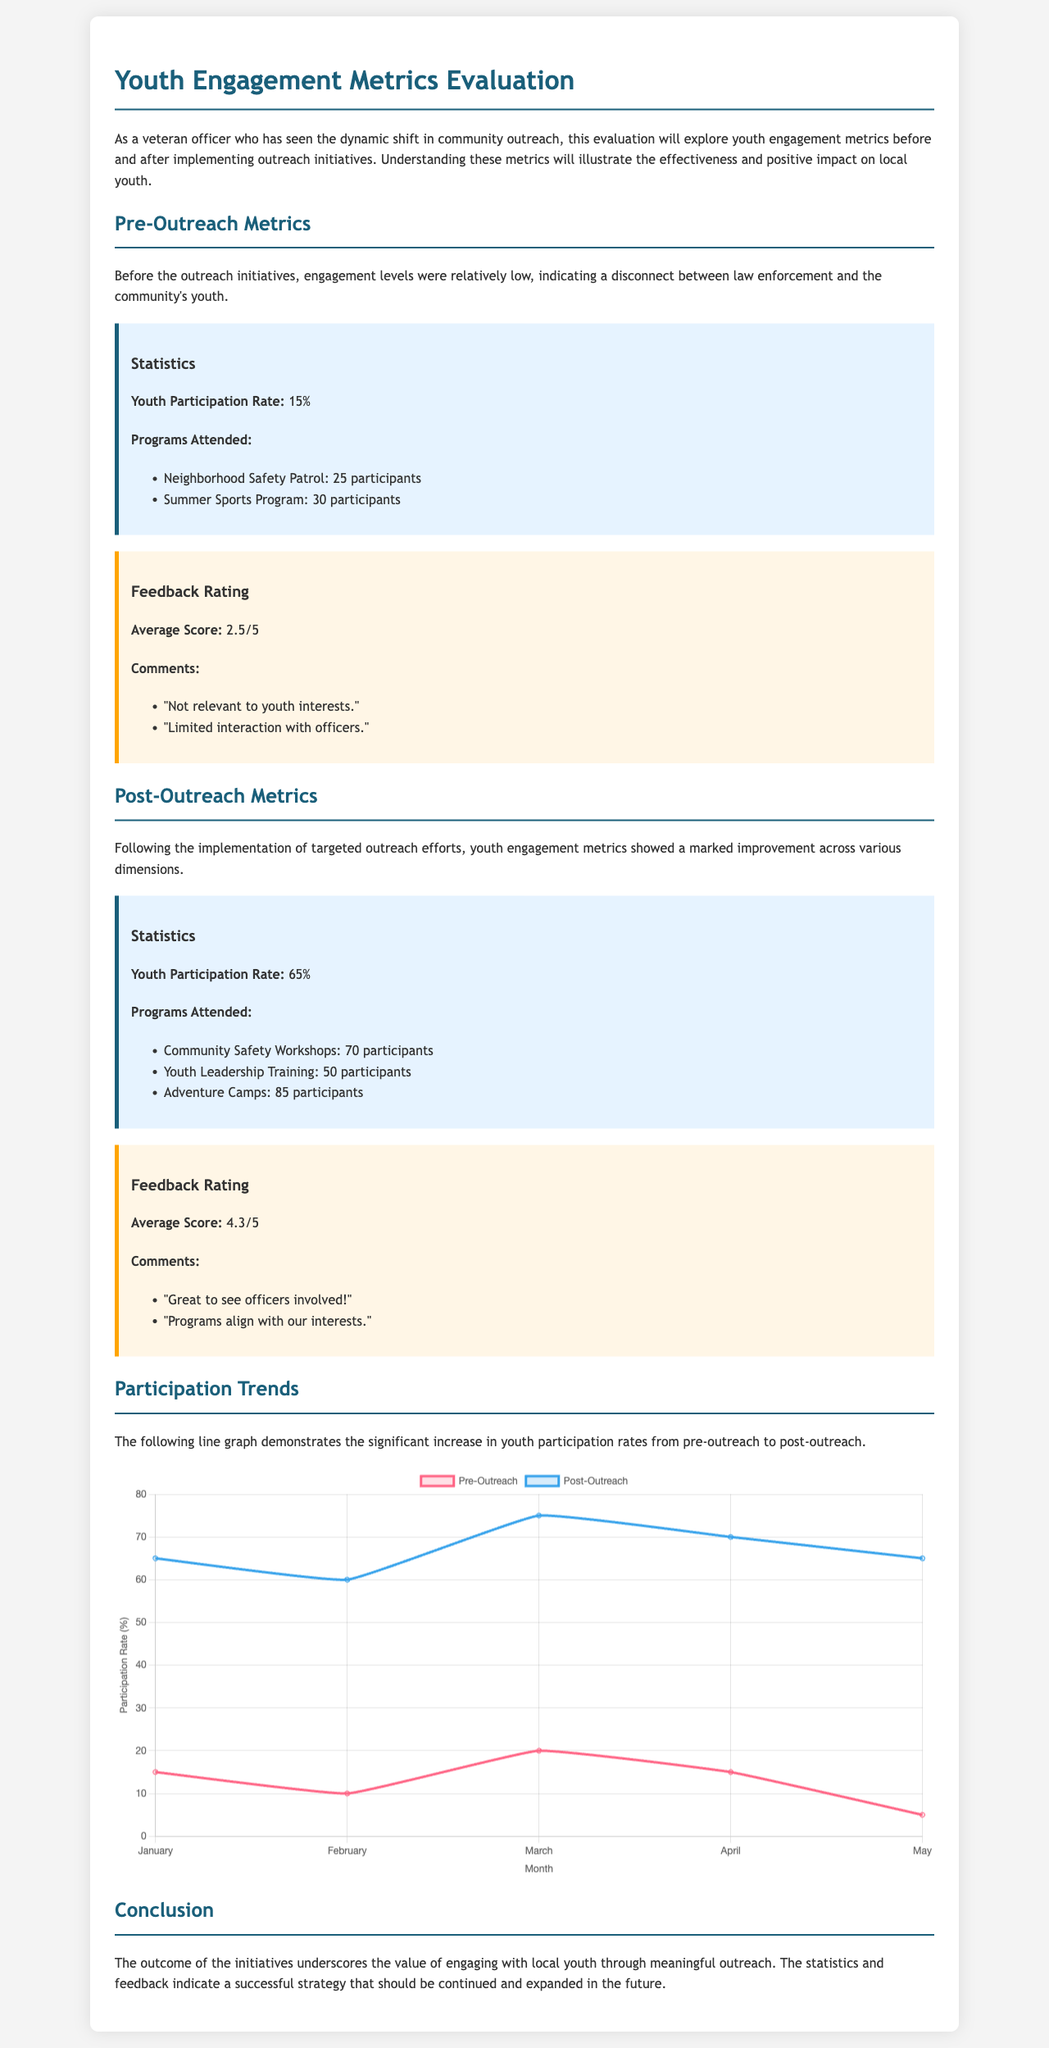What was the youth participation rate before outreach? The youth participation rate before outreach is stated directly in the document.
Answer: 15% What is the average feedback rating post-outreach? The average feedback rating is directly mentioned in the feedback section for post-outreach.
Answer: 4.3/5 How many participants attended the Adventure Camps? The number of participants for the Adventure Camps is listed under the programs attended post-outreach.
Answer: 85 participants What were the comments regarding the pre-outreach feedback? Specific comments provide insight into the feedback before outreach, stated in the feedback section.
Answer: "Not relevant to youth interests." What does the line graph illustrate? The graph visually compares youth participation rates pre- and post-outreach, as explained in the text.
Answer: Increase in youth participation rates How many participants were there in the Neighborhood Safety Patrol program? The specific number of participants in the Neighborhood Safety Patrol is provided in the document under pre-outreach statistics.
Answer: 25 participants Which month shows the lowest pre-outreach participation rate? The data displayed in the line graph indicates trends in participation across different months.
Answer: May What type of programs showed improvement in participation after outreach? The programs listed after outreach provide evidence of increased participation levels compared to pre-outreach statistics.
Answer: Community Safety Workshops What was the feedback related to officer involvement post-outreach? The feedback section highlights the change in perception towards officers' involvement after outreach, reflecting community sentiment.
Answer: "Great to see officers involved!" 